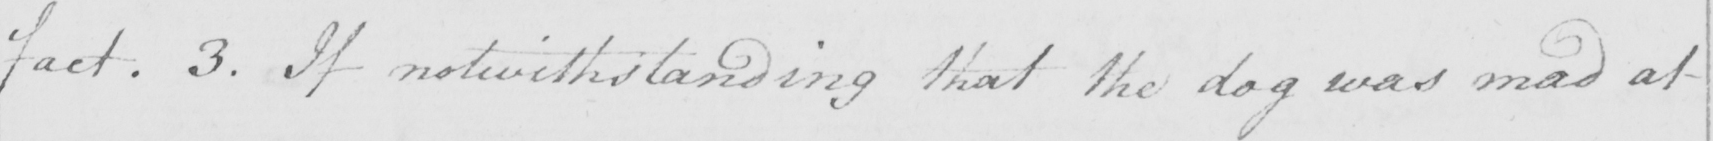Please provide the text content of this handwritten line. fact . 3 . If notwithstanding that the dog was mad at 